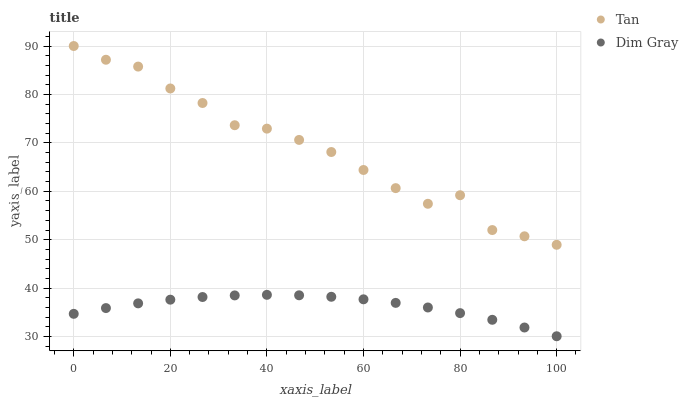Does Dim Gray have the minimum area under the curve?
Answer yes or no. Yes. Does Tan have the maximum area under the curve?
Answer yes or no. Yes. Does Dim Gray have the maximum area under the curve?
Answer yes or no. No. Is Dim Gray the smoothest?
Answer yes or no. Yes. Is Tan the roughest?
Answer yes or no. Yes. Is Dim Gray the roughest?
Answer yes or no. No. Does Dim Gray have the lowest value?
Answer yes or no. Yes. Does Tan have the highest value?
Answer yes or no. Yes. Does Dim Gray have the highest value?
Answer yes or no. No. Is Dim Gray less than Tan?
Answer yes or no. Yes. Is Tan greater than Dim Gray?
Answer yes or no. Yes. Does Dim Gray intersect Tan?
Answer yes or no. No. 